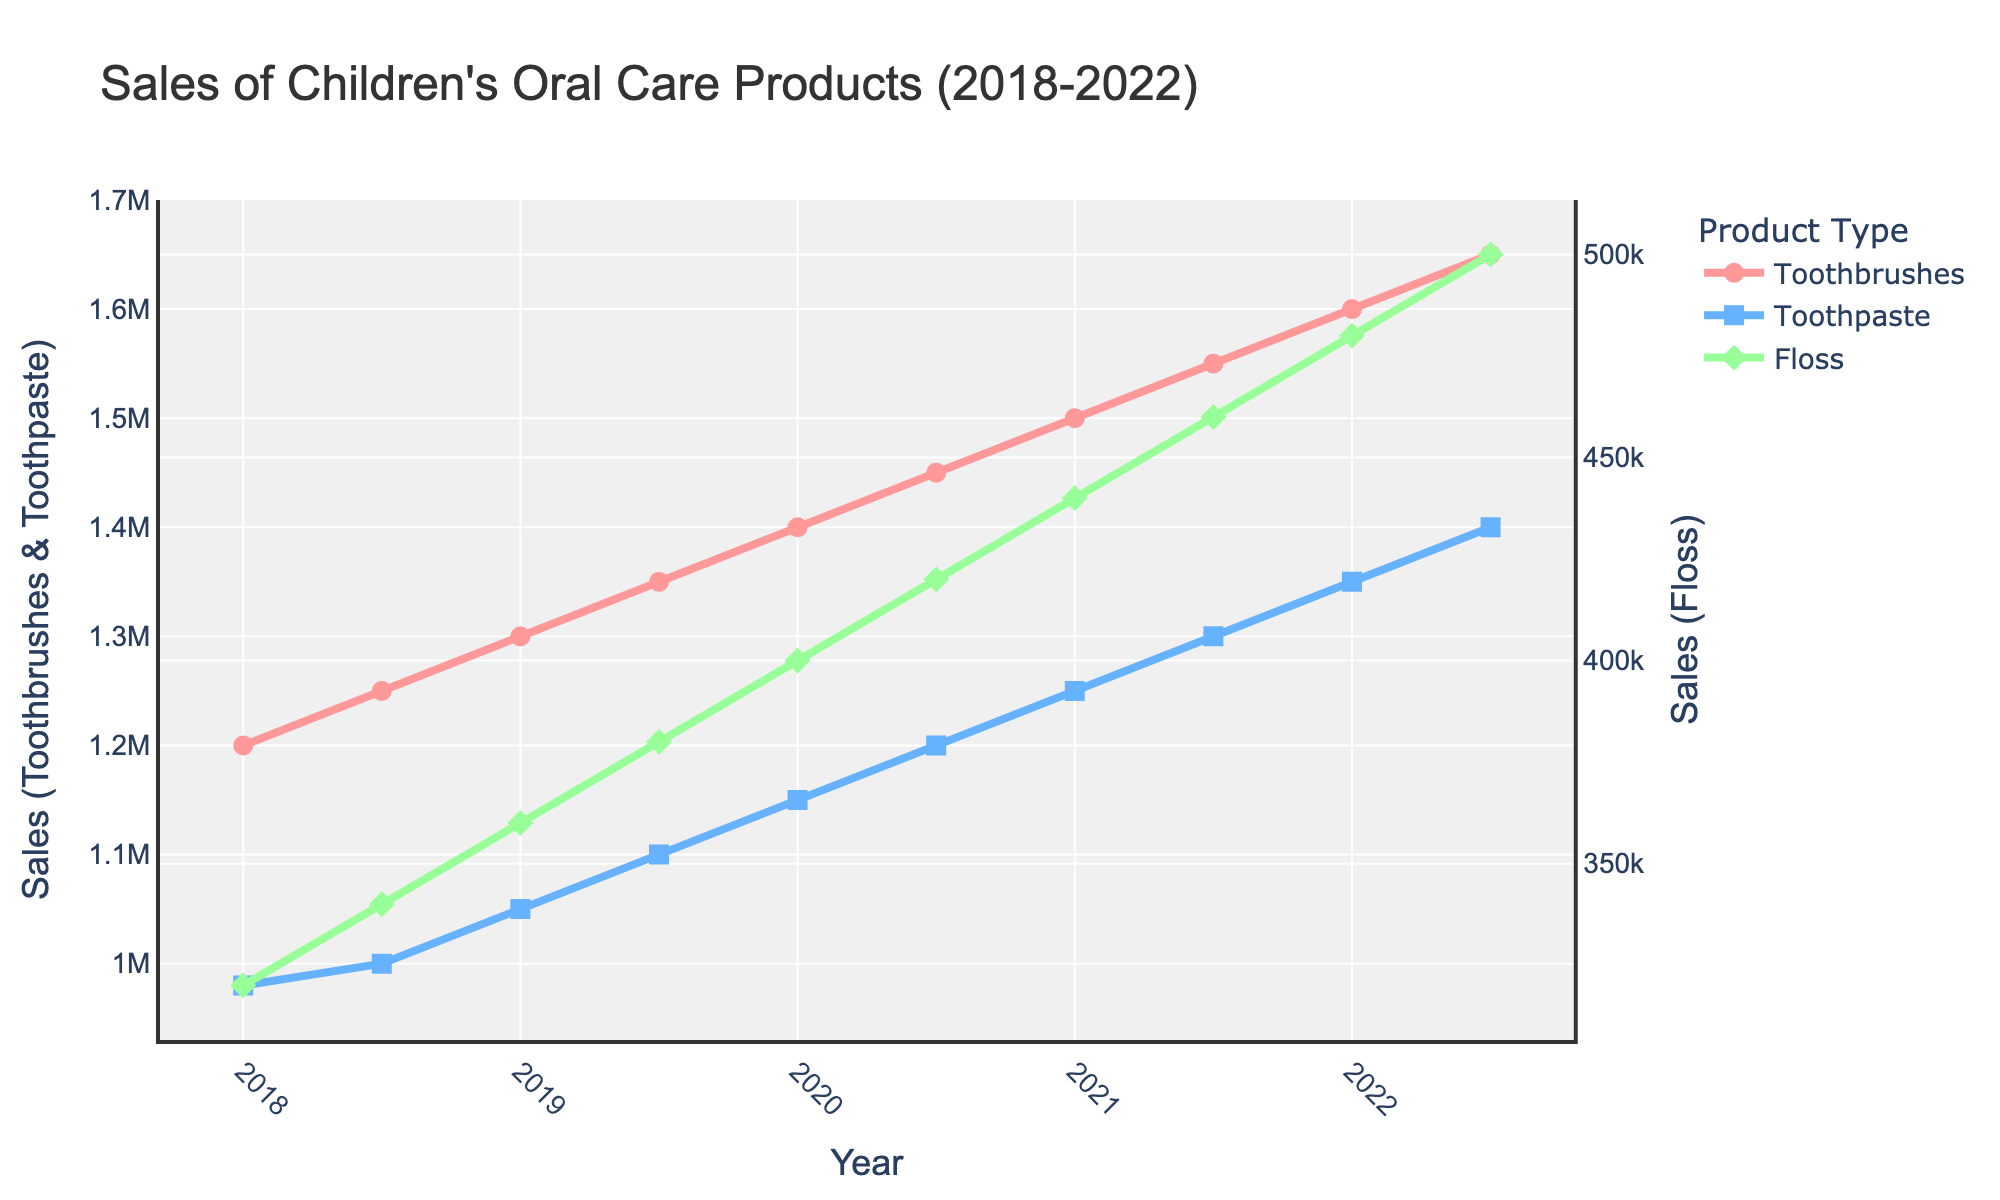what is the overall trend for the sales of toothbrushes over the 5-year period? By looking at the line representing toothbrush sales, it generally shows an upward trend from 2018 to 2022, indicating an increase in sales over time.
Answer: increasing which product type had the highest sales in 2022? By examining the endpoints of the lines in 2022, the toothbrush line is the highest, followed by toothpaste and floss. Thus, toothbrushes had the highest sales.
Answer: toothbrushes how much did the sales of floss increase from 2018 to 2022? To calculate this, subtract the sales of floss in 2018 (320,000) from the sales in 2022 (500,000). The difference is 500,000 - 320,000 = 180,000.
Answer: 180,000 which year saw the highest sales for toothpaste? By following the blue line representing toothpaste sales, the highest point is at the end of 2022.
Answer: 2022 compare the growth rates of toothbrushes and toothpaste from 2018 to 2020. Toothbrush sales in 2018 were 1,200,000, and in 2020 they were 1,400,000. This is an increase of 200,000. Toothpaste sales in 2018 were 980,000, and in 2020 they were 1,150,000, an increase of 170,000. Therefore, the growth rate of toothbrushes is higher.
Answer: toothbrushes what is the sales difference between toothpaste and floss in 2019? Floss sales in 2019 were 360,000, and toothpaste sales in 2019 were 1,050,000. The difference is 1,050,000 - 360,000 = 690,000.
Answer: 690,000 calculate the average sales of toothbrushes over the 5-year period. Sum the sales of toothbrushes at all time points and divide by the number of data points. (1,200,000 + 1,250,000 + 1,300,000 + 1,350,000 + 1,400,000 + 1,450,000 + 1,500,000 + 1,550,000 + 1,600,000 + 1,650,000) / 10 = 14,250,000 / 10 = 1,425,000.
Answer: 1,425,000 in which year did all three product types have the least sales difference? From the lines in the plot, 2018 shows the smallest difference between the sales of toothbrushes, toothpaste, and floss.
Answer: 2018 compare the sales increase for toothbrushes and floss from 2018.5 to 2021.5. Toothbrush sales increased from 1,250,000 (2018.5) to 1,550,000 (2021.5), a difference of 300,000. Floss sales increased from 340,000 (2018.5) to 460,000 (2021.5), a difference of 120,000. Therefore, the sales increase for toothbrushes is larger.
Answer: toothbrushes 